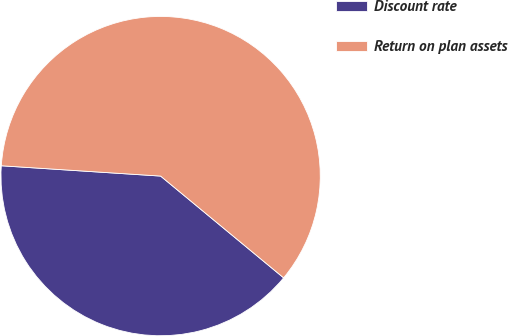<chart> <loc_0><loc_0><loc_500><loc_500><pie_chart><fcel>Discount rate<fcel>Return on plan assets<nl><fcel>40.03%<fcel>59.97%<nl></chart> 